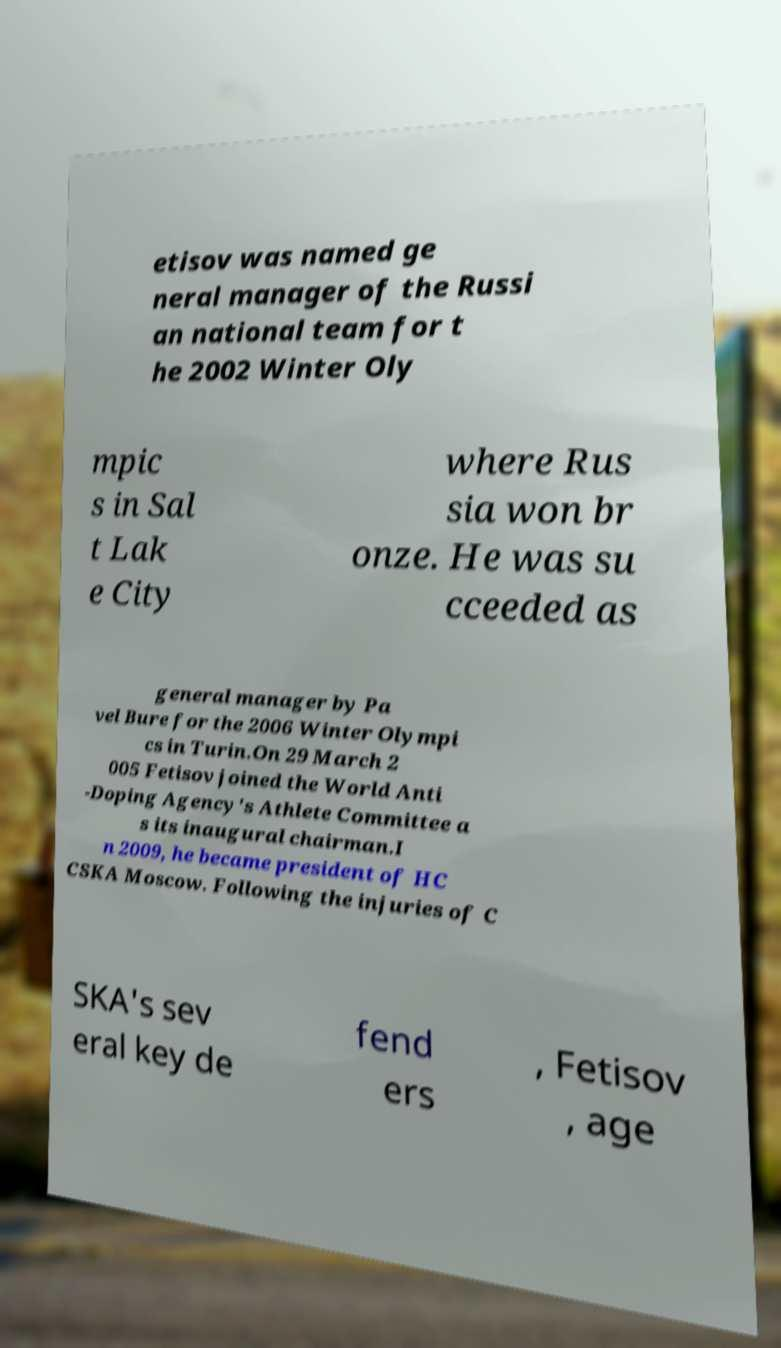For documentation purposes, I need the text within this image transcribed. Could you provide that? etisov was named ge neral manager of the Russi an national team for t he 2002 Winter Oly mpic s in Sal t Lak e City where Rus sia won br onze. He was su cceeded as general manager by Pa vel Bure for the 2006 Winter Olympi cs in Turin.On 29 March 2 005 Fetisov joined the World Anti -Doping Agency's Athlete Committee a s its inaugural chairman.I n 2009, he became president of HC CSKA Moscow. Following the injuries of C SKA's sev eral key de fend ers , Fetisov , age 